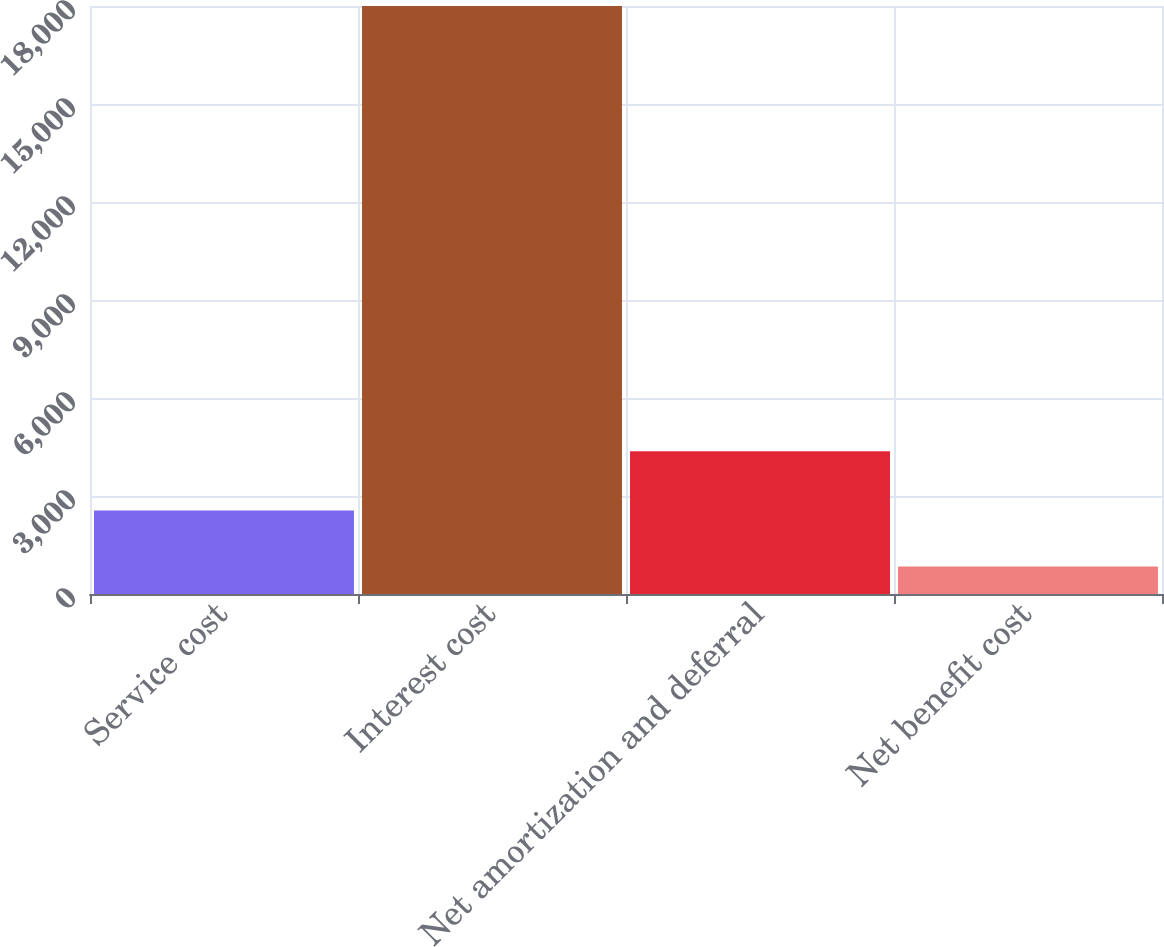Convert chart to OTSL. <chart><loc_0><loc_0><loc_500><loc_500><bar_chart><fcel>Service cost<fcel>Interest cost<fcel>Net amortization and deferral<fcel>Net benefit cost<nl><fcel>2556.9<fcel>18000<fcel>4371<fcel>841<nl></chart> 